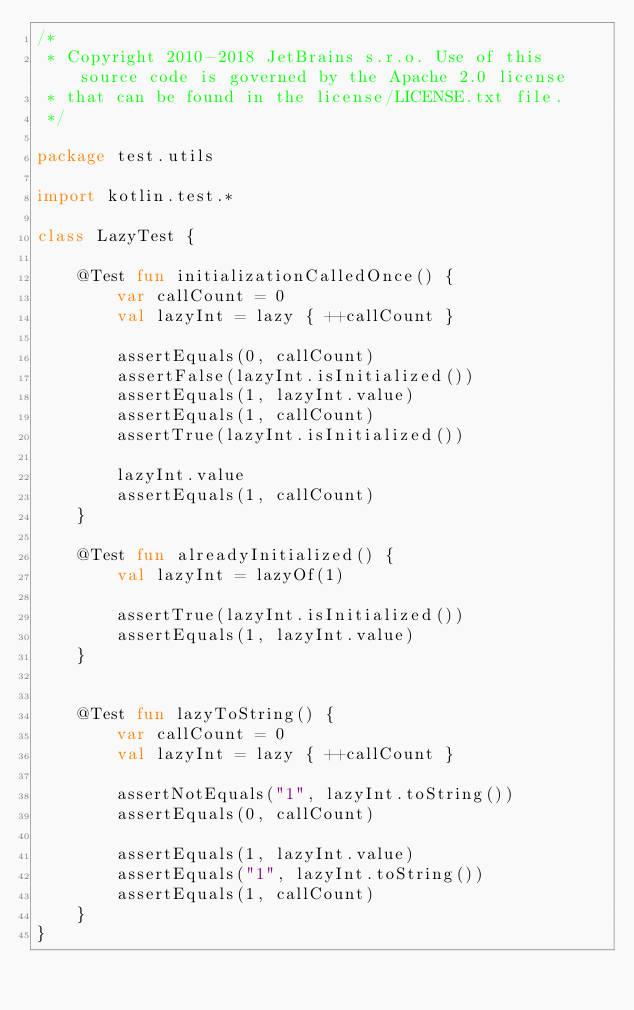<code> <loc_0><loc_0><loc_500><loc_500><_Kotlin_>/*
 * Copyright 2010-2018 JetBrains s.r.o. Use of this source code is governed by the Apache 2.0 license
 * that can be found in the license/LICENSE.txt file.
 */

package test.utils

import kotlin.test.*

class LazyTest {

    @Test fun initializationCalledOnce() {
        var callCount = 0
        val lazyInt = lazy { ++callCount }

        assertEquals(0, callCount)
        assertFalse(lazyInt.isInitialized())
        assertEquals(1, lazyInt.value)
        assertEquals(1, callCount)
        assertTrue(lazyInt.isInitialized())

        lazyInt.value
        assertEquals(1, callCount)
    }

    @Test fun alreadyInitialized() {
        val lazyInt = lazyOf(1)

        assertTrue(lazyInt.isInitialized())
        assertEquals(1, lazyInt.value)
    }


    @Test fun lazyToString() {
        var callCount = 0
        val lazyInt = lazy { ++callCount }

        assertNotEquals("1", lazyInt.toString())
        assertEquals(0, callCount)

        assertEquals(1, lazyInt.value)
        assertEquals("1", lazyInt.toString())
        assertEquals(1, callCount)
    }
}
</code> 